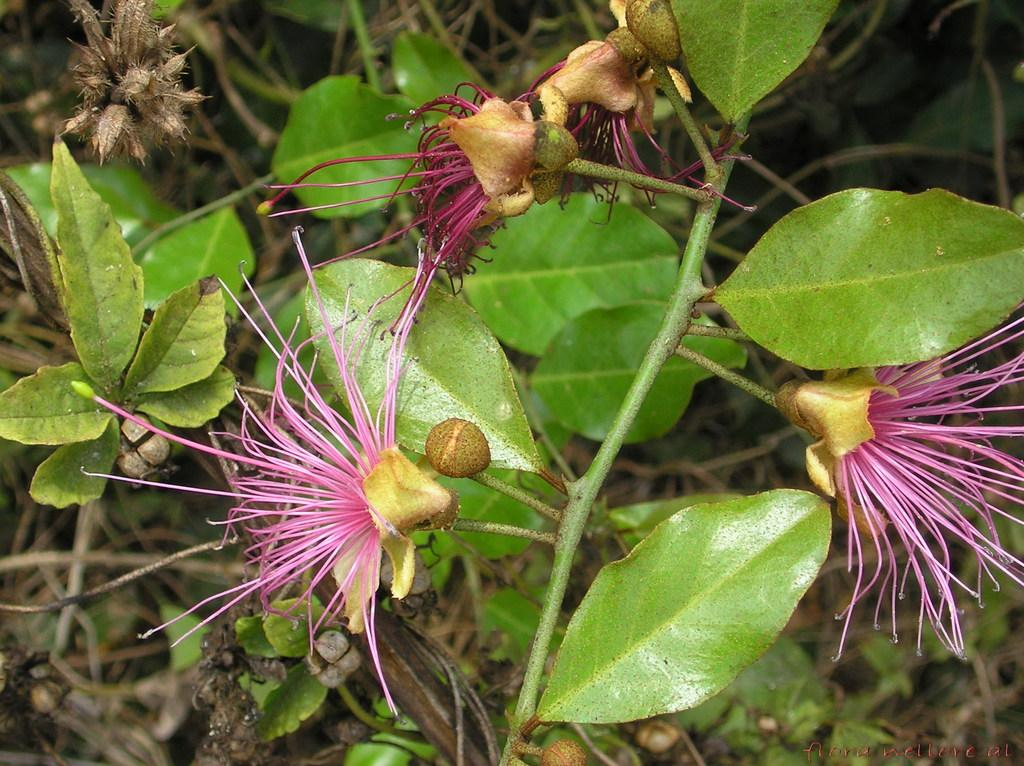What is present in the image? There is a plant in the image. What specific features does the plant have? The plant has flowers and green leaves. Can you see a donkey with a metal tail in the image? No, there is no donkey or metal tail present in the image. 